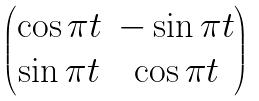<formula> <loc_0><loc_0><loc_500><loc_500>\begin{pmatrix} \cos \pi t & - \sin \pi t \\ \sin \pi t & \cos \pi t \end{pmatrix}</formula> 